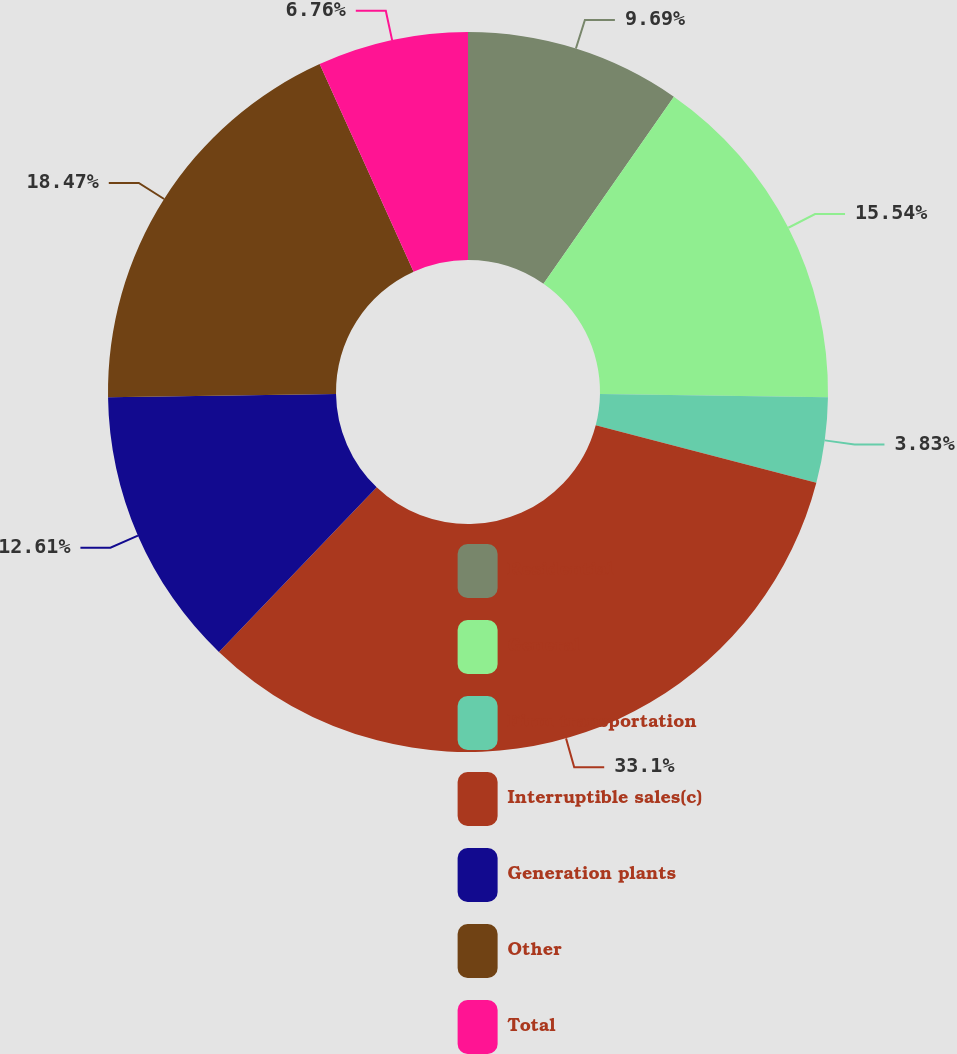Convert chart. <chart><loc_0><loc_0><loc_500><loc_500><pie_chart><fcel>Residential<fcel>General<fcel>Firm transportation<fcel>Interruptible sales(c)<fcel>Generation plants<fcel>Other<fcel>Total<nl><fcel>9.69%<fcel>15.54%<fcel>3.83%<fcel>33.1%<fcel>12.61%<fcel>18.47%<fcel>6.76%<nl></chart> 